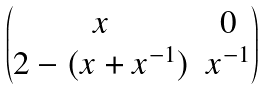<formula> <loc_0><loc_0><loc_500><loc_500>\begin{pmatrix} x & 0 \\ 2 - ( x + x ^ { - 1 } ) & x ^ { - 1 } \end{pmatrix}</formula> 